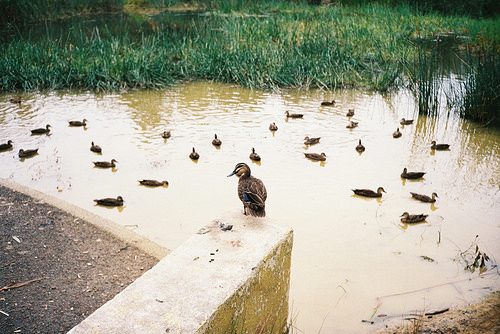<image>
Is the duck on the wall? Yes. Looking at the image, I can see the duck is positioned on top of the wall, with the wall providing support. 